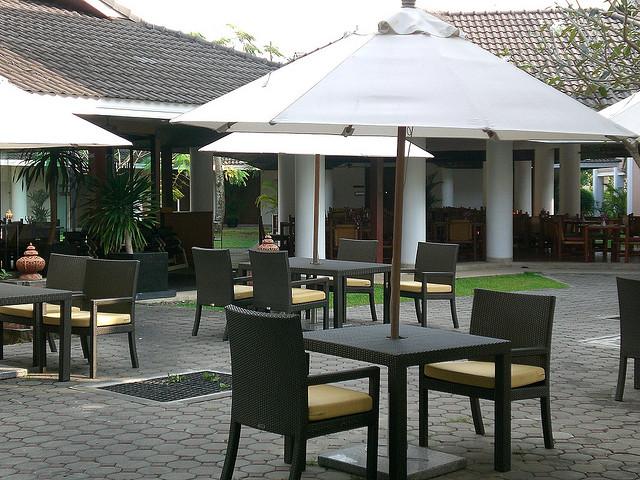Is this a restaurant?
Write a very short answer. Yes. What color are the chairs?
Concise answer only. Black and tan. How many chairs can you see?
Concise answer only. 9. Is it indoor or outdoor seating?
Keep it brief. Outdoor. How many chairs at the 3 tables?
Quick response, please. 8. 